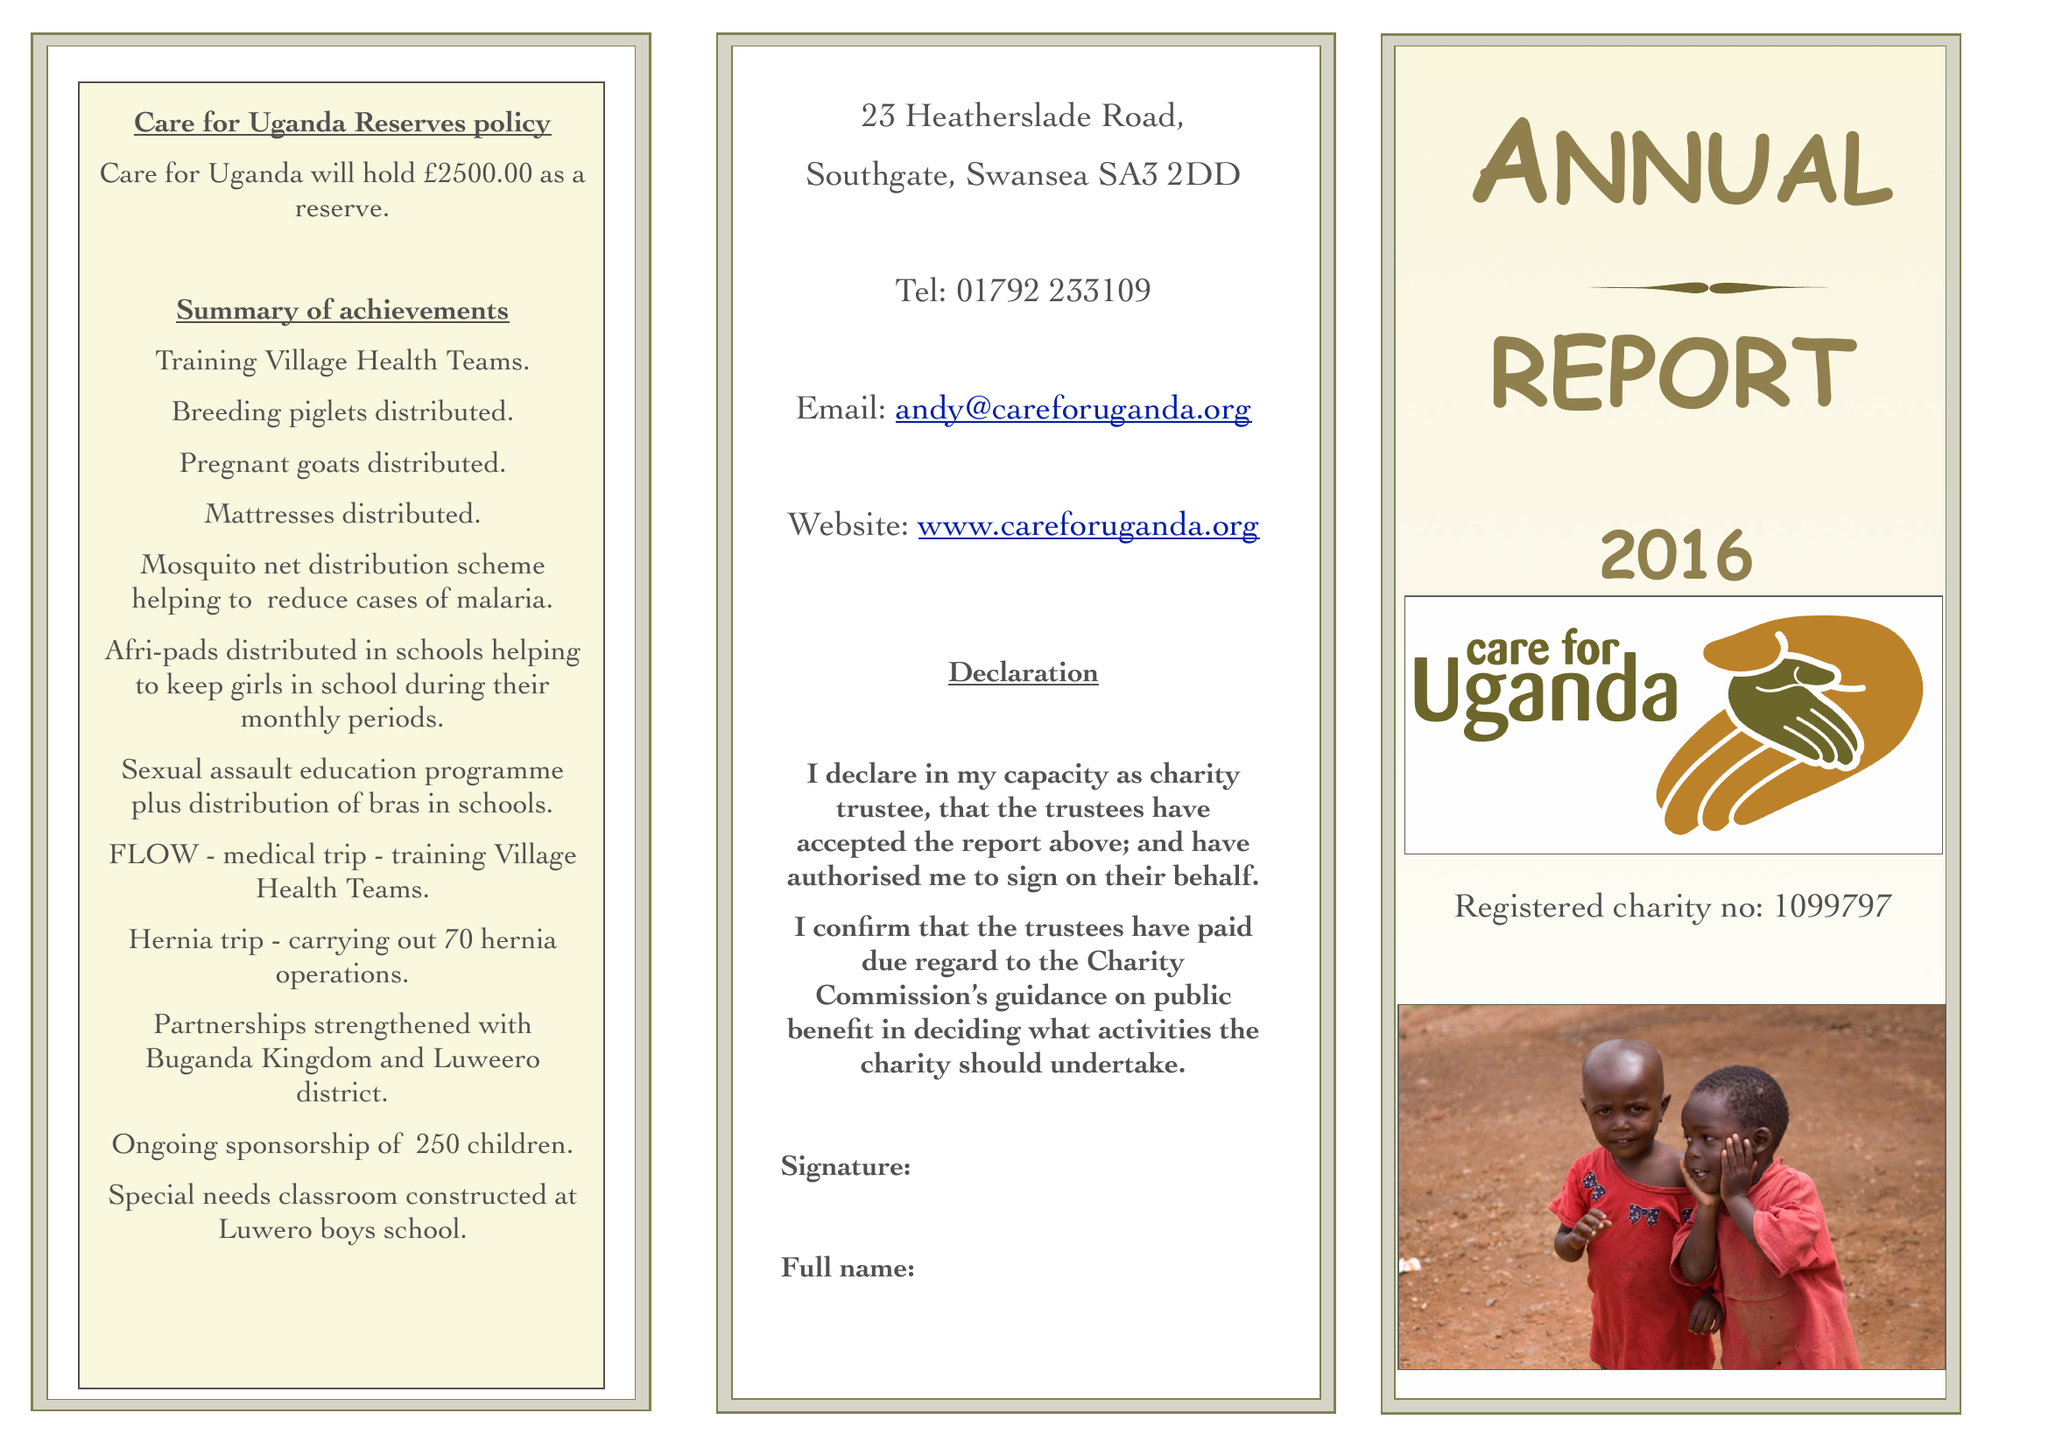What is the value for the charity_number?
Answer the question using a single word or phrase. 1099797 